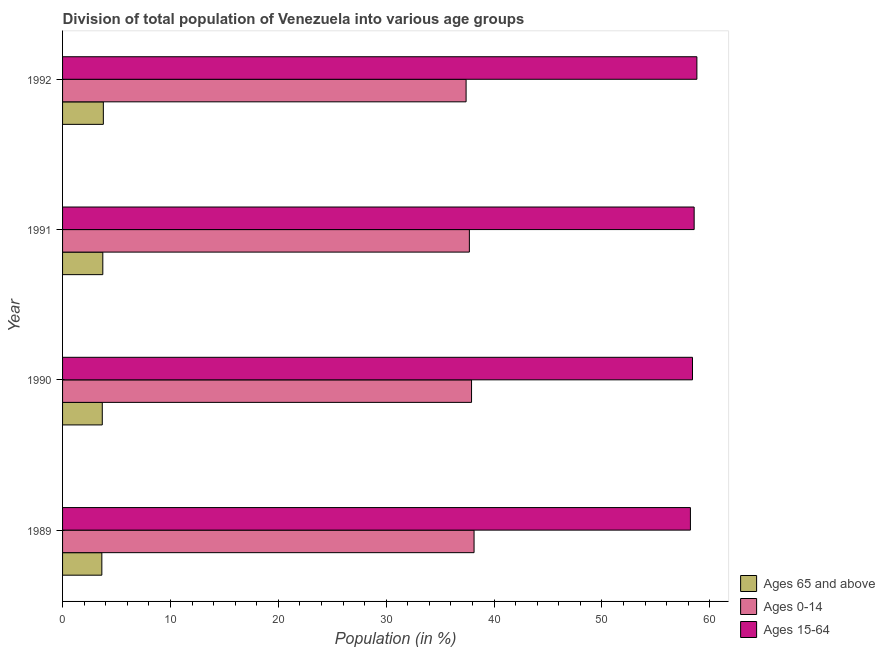How many different coloured bars are there?
Your answer should be compact. 3. How many groups of bars are there?
Your answer should be very brief. 4. How many bars are there on the 4th tick from the bottom?
Your answer should be compact. 3. What is the label of the 1st group of bars from the top?
Your answer should be compact. 1992. What is the percentage of population within the age-group of 65 and above in 1992?
Give a very brief answer. 3.78. Across all years, what is the maximum percentage of population within the age-group 0-14?
Your response must be concise. 38.15. Across all years, what is the minimum percentage of population within the age-group 15-64?
Your answer should be compact. 58.21. In which year was the percentage of population within the age-group 15-64 maximum?
Keep it short and to the point. 1992. In which year was the percentage of population within the age-group 0-14 minimum?
Provide a short and direct response. 1992. What is the total percentage of population within the age-group 15-64 in the graph?
Give a very brief answer. 233.97. What is the difference between the percentage of population within the age-group 15-64 in 1990 and the percentage of population within the age-group 0-14 in 1991?
Your answer should be very brief. 20.69. What is the average percentage of population within the age-group 15-64 per year?
Provide a short and direct response. 58.49. In the year 1991, what is the difference between the percentage of population within the age-group 15-64 and percentage of population within the age-group of 65 and above?
Ensure brevity in your answer.  54.82. In how many years, is the percentage of population within the age-group of 65 and above greater than 56 %?
Your response must be concise. 0. Is the difference between the percentage of population within the age-group of 65 and above in 1990 and 1992 greater than the difference between the percentage of population within the age-group 0-14 in 1990 and 1992?
Your answer should be very brief. No. What is the difference between the highest and the second highest percentage of population within the age-group 0-14?
Your answer should be compact. 0.23. What is the difference between the highest and the lowest percentage of population within the age-group of 65 and above?
Make the answer very short. 0.14. What does the 2nd bar from the top in 1992 represents?
Ensure brevity in your answer.  Ages 0-14. What does the 3rd bar from the bottom in 1991 represents?
Provide a short and direct response. Ages 15-64. Is it the case that in every year, the sum of the percentage of population within the age-group of 65 and above and percentage of population within the age-group 0-14 is greater than the percentage of population within the age-group 15-64?
Give a very brief answer. No. How many bars are there?
Make the answer very short. 12. Are the values on the major ticks of X-axis written in scientific E-notation?
Your response must be concise. No. Does the graph contain any zero values?
Keep it short and to the point. No. Does the graph contain grids?
Your answer should be compact. No. What is the title of the graph?
Offer a very short reply. Division of total population of Venezuela into various age groups
. What is the label or title of the X-axis?
Keep it short and to the point. Population (in %). What is the label or title of the Y-axis?
Ensure brevity in your answer.  Year. What is the Population (in %) in Ages 65 and above in 1989?
Ensure brevity in your answer.  3.64. What is the Population (in %) of Ages 0-14 in 1989?
Keep it short and to the point. 38.15. What is the Population (in %) in Ages 15-64 in 1989?
Keep it short and to the point. 58.21. What is the Population (in %) in Ages 65 and above in 1990?
Your answer should be very brief. 3.68. What is the Population (in %) of Ages 0-14 in 1990?
Offer a very short reply. 37.92. What is the Population (in %) of Ages 15-64 in 1990?
Provide a succinct answer. 58.4. What is the Population (in %) in Ages 65 and above in 1991?
Provide a succinct answer. 3.73. What is the Population (in %) in Ages 0-14 in 1991?
Make the answer very short. 37.71. What is the Population (in %) in Ages 15-64 in 1991?
Give a very brief answer. 58.55. What is the Population (in %) in Ages 65 and above in 1992?
Your response must be concise. 3.78. What is the Population (in %) of Ages 0-14 in 1992?
Ensure brevity in your answer.  37.41. What is the Population (in %) in Ages 15-64 in 1992?
Your answer should be compact. 58.81. Across all years, what is the maximum Population (in %) in Ages 65 and above?
Your answer should be compact. 3.78. Across all years, what is the maximum Population (in %) of Ages 0-14?
Provide a succinct answer. 38.15. Across all years, what is the maximum Population (in %) of Ages 15-64?
Your answer should be compact. 58.81. Across all years, what is the minimum Population (in %) in Ages 65 and above?
Your answer should be very brief. 3.64. Across all years, what is the minimum Population (in %) in Ages 0-14?
Give a very brief answer. 37.41. Across all years, what is the minimum Population (in %) in Ages 15-64?
Offer a very short reply. 58.21. What is the total Population (in %) of Ages 65 and above in the graph?
Your answer should be very brief. 14.84. What is the total Population (in %) of Ages 0-14 in the graph?
Offer a terse response. 151.19. What is the total Population (in %) in Ages 15-64 in the graph?
Provide a short and direct response. 233.97. What is the difference between the Population (in %) of Ages 65 and above in 1989 and that in 1990?
Ensure brevity in your answer.  -0.04. What is the difference between the Population (in %) in Ages 0-14 in 1989 and that in 1990?
Provide a succinct answer. 0.23. What is the difference between the Population (in %) of Ages 15-64 in 1989 and that in 1990?
Your response must be concise. -0.19. What is the difference between the Population (in %) of Ages 65 and above in 1989 and that in 1991?
Offer a terse response. -0.09. What is the difference between the Population (in %) of Ages 0-14 in 1989 and that in 1991?
Keep it short and to the point. 0.43. What is the difference between the Population (in %) of Ages 15-64 in 1989 and that in 1991?
Give a very brief answer. -0.35. What is the difference between the Population (in %) in Ages 65 and above in 1989 and that in 1992?
Provide a short and direct response. -0.14. What is the difference between the Population (in %) in Ages 0-14 in 1989 and that in 1992?
Offer a very short reply. 0.74. What is the difference between the Population (in %) of Ages 15-64 in 1989 and that in 1992?
Provide a succinct answer. -0.6. What is the difference between the Population (in %) of Ages 65 and above in 1990 and that in 1991?
Offer a very short reply. -0.05. What is the difference between the Population (in %) in Ages 0-14 in 1990 and that in 1991?
Provide a succinct answer. 0.2. What is the difference between the Population (in %) of Ages 15-64 in 1990 and that in 1991?
Keep it short and to the point. -0.15. What is the difference between the Population (in %) of Ages 65 and above in 1990 and that in 1992?
Offer a very short reply. -0.1. What is the difference between the Population (in %) of Ages 0-14 in 1990 and that in 1992?
Your response must be concise. 0.51. What is the difference between the Population (in %) in Ages 15-64 in 1990 and that in 1992?
Keep it short and to the point. -0.41. What is the difference between the Population (in %) of Ages 65 and above in 1991 and that in 1992?
Keep it short and to the point. -0.05. What is the difference between the Population (in %) of Ages 0-14 in 1991 and that in 1992?
Provide a short and direct response. 0.3. What is the difference between the Population (in %) in Ages 15-64 in 1991 and that in 1992?
Make the answer very short. -0.25. What is the difference between the Population (in %) of Ages 65 and above in 1989 and the Population (in %) of Ages 0-14 in 1990?
Your answer should be compact. -34.27. What is the difference between the Population (in %) in Ages 65 and above in 1989 and the Population (in %) in Ages 15-64 in 1990?
Provide a short and direct response. -54.76. What is the difference between the Population (in %) in Ages 0-14 in 1989 and the Population (in %) in Ages 15-64 in 1990?
Offer a terse response. -20.25. What is the difference between the Population (in %) of Ages 65 and above in 1989 and the Population (in %) of Ages 0-14 in 1991?
Give a very brief answer. -34.07. What is the difference between the Population (in %) in Ages 65 and above in 1989 and the Population (in %) in Ages 15-64 in 1991?
Your response must be concise. -54.91. What is the difference between the Population (in %) in Ages 0-14 in 1989 and the Population (in %) in Ages 15-64 in 1991?
Make the answer very short. -20.4. What is the difference between the Population (in %) of Ages 65 and above in 1989 and the Population (in %) of Ages 0-14 in 1992?
Give a very brief answer. -33.77. What is the difference between the Population (in %) of Ages 65 and above in 1989 and the Population (in %) of Ages 15-64 in 1992?
Ensure brevity in your answer.  -55.17. What is the difference between the Population (in %) of Ages 0-14 in 1989 and the Population (in %) of Ages 15-64 in 1992?
Ensure brevity in your answer.  -20.66. What is the difference between the Population (in %) of Ages 65 and above in 1990 and the Population (in %) of Ages 0-14 in 1991?
Provide a succinct answer. -34.03. What is the difference between the Population (in %) in Ages 65 and above in 1990 and the Population (in %) in Ages 15-64 in 1991?
Your answer should be compact. -54.87. What is the difference between the Population (in %) of Ages 0-14 in 1990 and the Population (in %) of Ages 15-64 in 1991?
Your answer should be very brief. -20.64. What is the difference between the Population (in %) in Ages 65 and above in 1990 and the Population (in %) in Ages 0-14 in 1992?
Make the answer very short. -33.73. What is the difference between the Population (in %) in Ages 65 and above in 1990 and the Population (in %) in Ages 15-64 in 1992?
Make the answer very short. -55.13. What is the difference between the Population (in %) of Ages 0-14 in 1990 and the Population (in %) of Ages 15-64 in 1992?
Give a very brief answer. -20.89. What is the difference between the Population (in %) in Ages 65 and above in 1991 and the Population (in %) in Ages 0-14 in 1992?
Provide a short and direct response. -33.68. What is the difference between the Population (in %) in Ages 65 and above in 1991 and the Population (in %) in Ages 15-64 in 1992?
Provide a succinct answer. -55.08. What is the difference between the Population (in %) in Ages 0-14 in 1991 and the Population (in %) in Ages 15-64 in 1992?
Keep it short and to the point. -21.09. What is the average Population (in %) of Ages 65 and above per year?
Provide a succinct answer. 3.71. What is the average Population (in %) in Ages 0-14 per year?
Offer a very short reply. 37.8. What is the average Population (in %) in Ages 15-64 per year?
Provide a short and direct response. 58.49. In the year 1989, what is the difference between the Population (in %) of Ages 65 and above and Population (in %) of Ages 0-14?
Offer a terse response. -34.51. In the year 1989, what is the difference between the Population (in %) of Ages 65 and above and Population (in %) of Ages 15-64?
Offer a very short reply. -54.57. In the year 1989, what is the difference between the Population (in %) of Ages 0-14 and Population (in %) of Ages 15-64?
Provide a succinct answer. -20.06. In the year 1990, what is the difference between the Population (in %) of Ages 65 and above and Population (in %) of Ages 0-14?
Give a very brief answer. -34.23. In the year 1990, what is the difference between the Population (in %) in Ages 65 and above and Population (in %) in Ages 15-64?
Provide a short and direct response. -54.72. In the year 1990, what is the difference between the Population (in %) in Ages 0-14 and Population (in %) in Ages 15-64?
Offer a very short reply. -20.48. In the year 1991, what is the difference between the Population (in %) of Ages 65 and above and Population (in %) of Ages 0-14?
Keep it short and to the point. -33.98. In the year 1991, what is the difference between the Population (in %) in Ages 65 and above and Population (in %) in Ages 15-64?
Keep it short and to the point. -54.82. In the year 1991, what is the difference between the Population (in %) of Ages 0-14 and Population (in %) of Ages 15-64?
Offer a terse response. -20.84. In the year 1992, what is the difference between the Population (in %) in Ages 65 and above and Population (in %) in Ages 0-14?
Provide a succinct answer. -33.63. In the year 1992, what is the difference between the Population (in %) in Ages 65 and above and Population (in %) in Ages 15-64?
Keep it short and to the point. -55.03. In the year 1992, what is the difference between the Population (in %) in Ages 0-14 and Population (in %) in Ages 15-64?
Ensure brevity in your answer.  -21.4. What is the ratio of the Population (in %) in Ages 65 and above in 1989 to that in 1990?
Your answer should be very brief. 0.99. What is the ratio of the Population (in %) in Ages 0-14 in 1989 to that in 1990?
Provide a short and direct response. 1.01. What is the ratio of the Population (in %) in Ages 15-64 in 1989 to that in 1990?
Your answer should be very brief. 1. What is the ratio of the Population (in %) in Ages 65 and above in 1989 to that in 1991?
Provide a short and direct response. 0.98. What is the ratio of the Population (in %) of Ages 0-14 in 1989 to that in 1991?
Your answer should be very brief. 1.01. What is the ratio of the Population (in %) of Ages 15-64 in 1989 to that in 1991?
Offer a terse response. 0.99. What is the ratio of the Population (in %) in Ages 65 and above in 1989 to that in 1992?
Offer a very short reply. 0.96. What is the ratio of the Population (in %) of Ages 0-14 in 1989 to that in 1992?
Make the answer very short. 1.02. What is the ratio of the Population (in %) of Ages 15-64 in 1989 to that in 1992?
Your answer should be very brief. 0.99. What is the ratio of the Population (in %) in Ages 0-14 in 1990 to that in 1991?
Offer a very short reply. 1.01. What is the ratio of the Population (in %) of Ages 15-64 in 1990 to that in 1991?
Your answer should be compact. 1. What is the ratio of the Population (in %) in Ages 65 and above in 1990 to that in 1992?
Your answer should be compact. 0.97. What is the ratio of the Population (in %) of Ages 0-14 in 1990 to that in 1992?
Keep it short and to the point. 1.01. What is the difference between the highest and the second highest Population (in %) of Ages 65 and above?
Offer a terse response. 0.05. What is the difference between the highest and the second highest Population (in %) of Ages 0-14?
Your response must be concise. 0.23. What is the difference between the highest and the second highest Population (in %) in Ages 15-64?
Your answer should be compact. 0.25. What is the difference between the highest and the lowest Population (in %) in Ages 65 and above?
Ensure brevity in your answer.  0.14. What is the difference between the highest and the lowest Population (in %) in Ages 0-14?
Keep it short and to the point. 0.74. What is the difference between the highest and the lowest Population (in %) in Ages 15-64?
Make the answer very short. 0.6. 